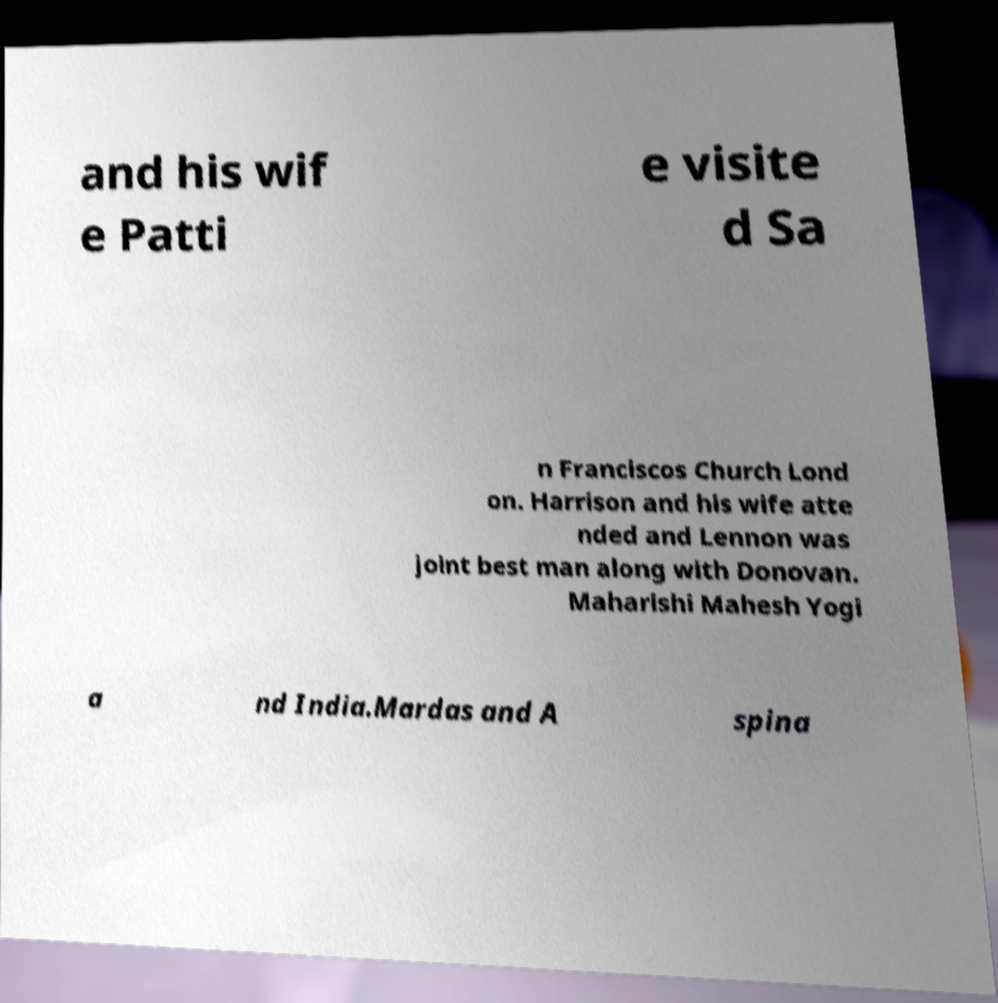Please identify and transcribe the text found in this image. and his wif e Patti e visite d Sa n Franciscos Church Lond on. Harrison and his wife atte nded and Lennon was joint best man along with Donovan. Maharishi Mahesh Yogi a nd India.Mardas and A spina 